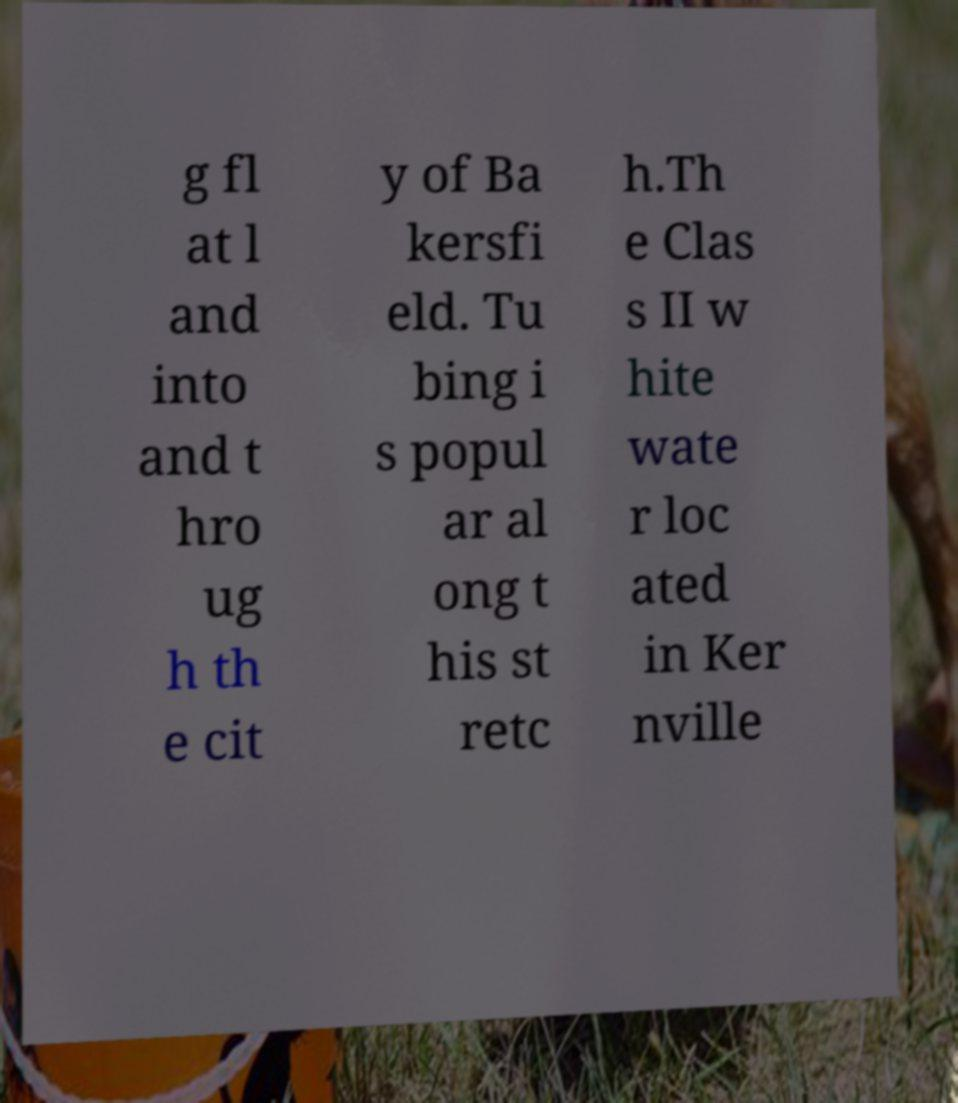Could you extract and type out the text from this image? g fl at l and into and t hro ug h th e cit y of Ba kersfi eld. Tu bing i s popul ar al ong t his st retc h.Th e Clas s II w hite wate r loc ated in Ker nville 